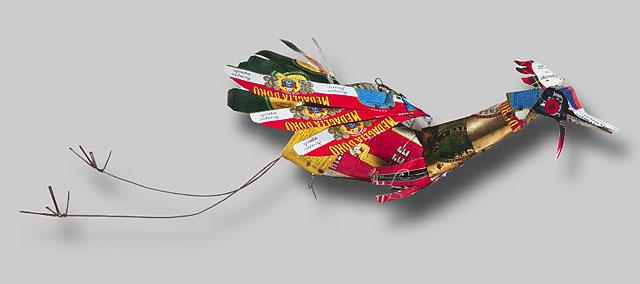Can you explain what the choice of materials and design says about themes of sustainability and recycling in art? Absolutely, this artwork made from recycled materials like tin cans and bottle caps speaks volumes about sustainability and the reusability of ordinary objects. By transforming discarded materials into a visually appealing sculpture, the artist makes a strong statement on the potential for repurposed items to find new life as art. This approach not only reduces waste but also encourages viewers to rethink their perceptions of trash and value, highlighting how art can play a role in environmental consciousness. 